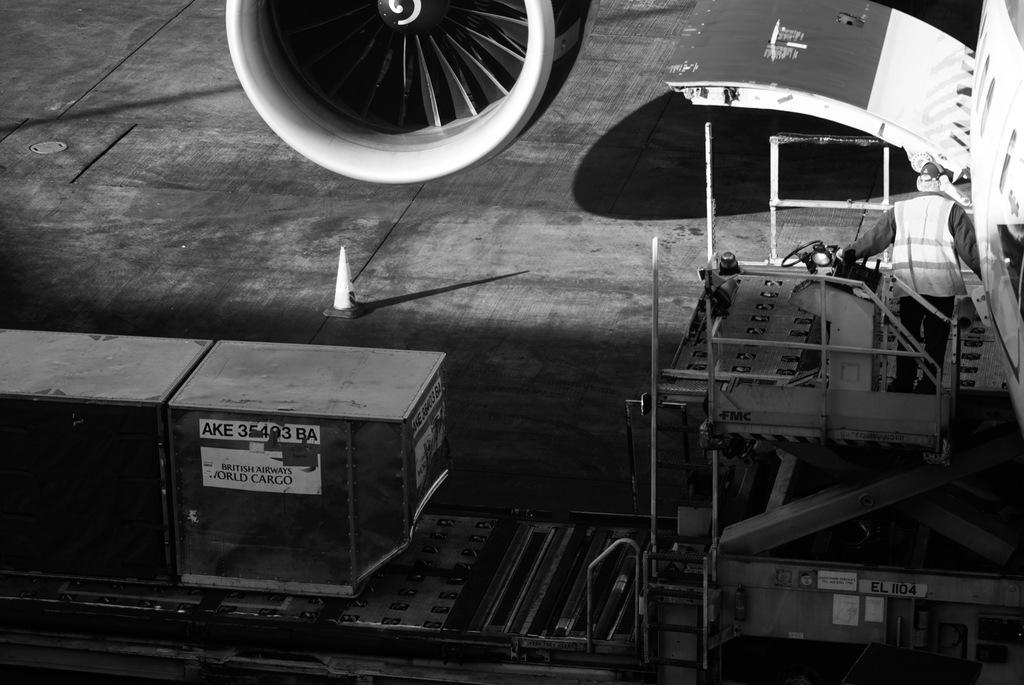Can you describe this image briefly? It looks like a black and white picture. We can see a man is standing on a stair tamer cargo lift. In front of the man there is an airplane and a turbine. On the left side of the man there is a cone barrier and a container. 